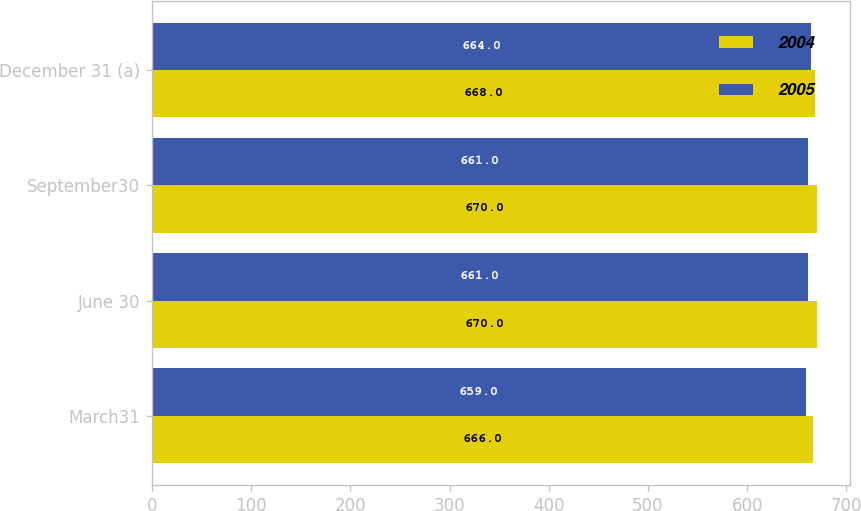Convert chart. <chart><loc_0><loc_0><loc_500><loc_500><stacked_bar_chart><ecel><fcel>March31<fcel>June 30<fcel>September30<fcel>December 31 (a)<nl><fcel>2004<fcel>666<fcel>670<fcel>670<fcel>668<nl><fcel>2005<fcel>659<fcel>661<fcel>661<fcel>664<nl></chart> 